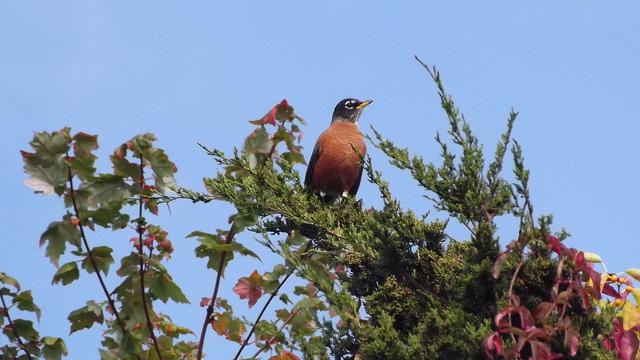What kind of bird is this?
Keep it brief. Robin. How many different trees can you identify in this picture?
Concise answer only. 2. What color is the bird's chest?
Keep it brief. Red. Is this a photo of a young immature scarlet tanager?
Give a very brief answer. No. Are there any trees in this pic?
Be succinct. Yes. 